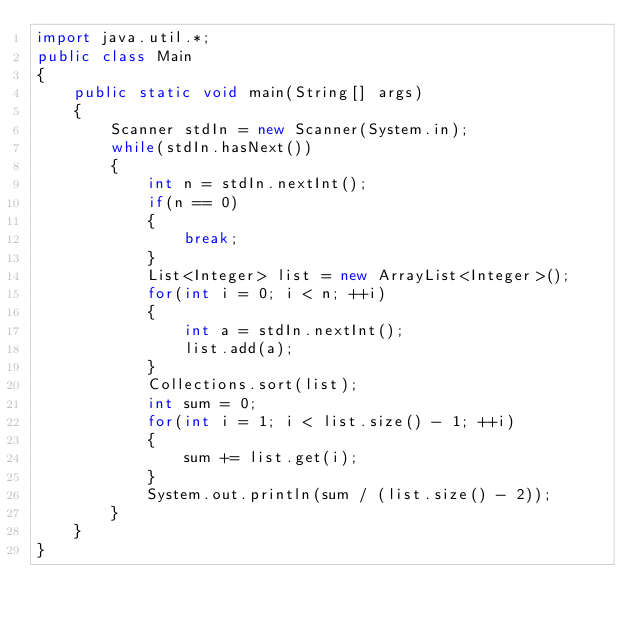Convert code to text. <code><loc_0><loc_0><loc_500><loc_500><_Java_>import java.util.*;
public class Main 
{
    public static void main(String[] args) 
    {
        Scanner stdIn = new Scanner(System.in);
        while(stdIn.hasNext())
        {
            int n = stdIn.nextInt();
            if(n == 0)
            {
                break;
            }
            List<Integer> list = new ArrayList<Integer>();
            for(int i = 0; i < n; ++i)
            {
                int a = stdIn.nextInt();
                list.add(a);
            }
            Collections.sort(list);
            int sum = 0;
            for(int i = 1; i < list.size() - 1; ++i)
            {
                sum += list.get(i);
            }
            System.out.println(sum / (list.size() - 2));
        }
    }
}
</code> 